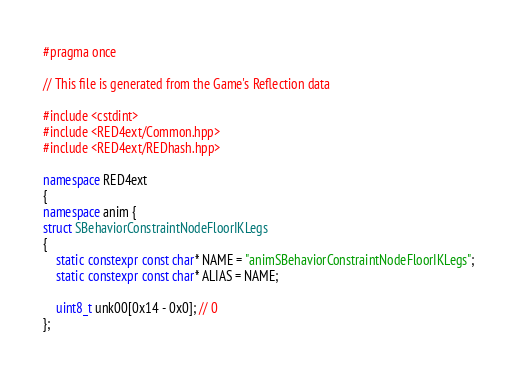Convert code to text. <code><loc_0><loc_0><loc_500><loc_500><_C++_>#pragma once

// This file is generated from the Game's Reflection data

#include <cstdint>
#include <RED4ext/Common.hpp>
#include <RED4ext/REDhash.hpp>

namespace RED4ext
{
namespace anim { 
struct SBehaviorConstraintNodeFloorIKLegs
{
    static constexpr const char* NAME = "animSBehaviorConstraintNodeFloorIKLegs";
    static constexpr const char* ALIAS = NAME;

    uint8_t unk00[0x14 - 0x0]; // 0
};</code> 